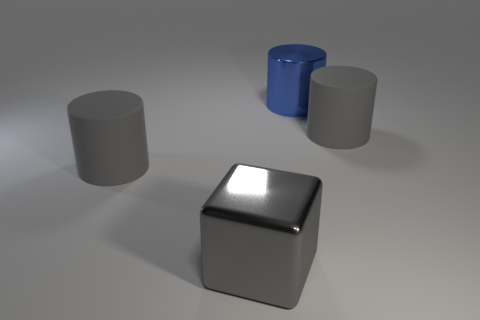There is a large shiny cube; is it the same color as the big matte cylinder that is right of the large gray cube?
Offer a terse response. Yes. There is a metal thing that is on the left side of the large blue thing; is its size the same as the cylinder to the right of the big blue metallic object?
Your response must be concise. Yes. Is there a big red object that has the same shape as the large blue metal thing?
Your answer should be compact. No. Is the number of big blue shiny cylinders that are on the left side of the blue metallic cylinder less than the number of big blue matte cubes?
Your answer should be very brief. No. There is a matte cylinder right of the cube; what size is it?
Ensure brevity in your answer.  Large. The gray block that is the same material as the large blue cylinder is what size?
Make the answer very short. Large. Is the number of large blue objects less than the number of big cylinders?
Your response must be concise. Yes. There is a blue object that is the same size as the gray metal cube; what material is it?
Make the answer very short. Metal. Is the number of large yellow shiny balls greater than the number of blue cylinders?
Offer a very short reply. No. What number of other objects are there of the same color as the cube?
Make the answer very short. 2. 